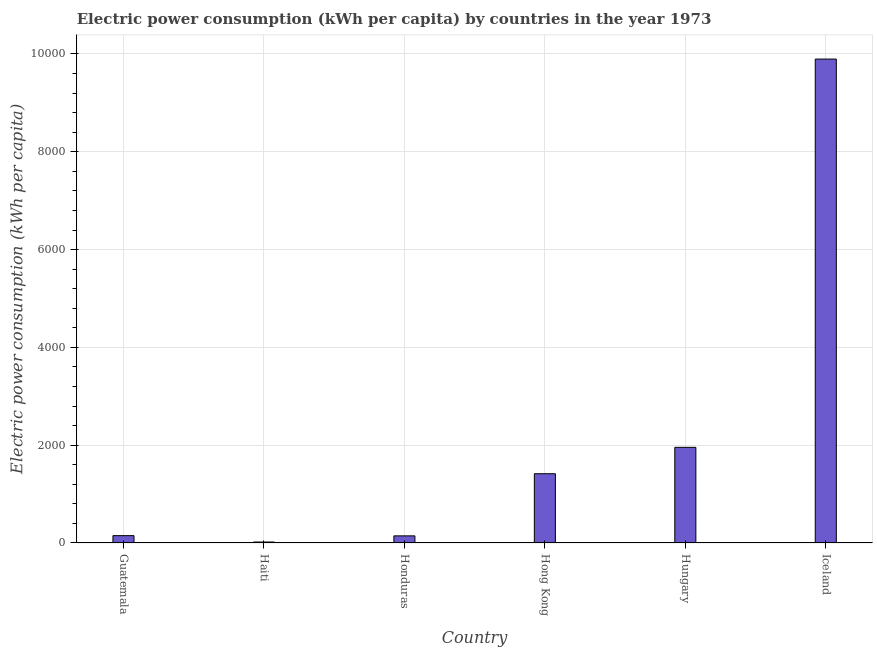Does the graph contain any zero values?
Your response must be concise. No. Does the graph contain grids?
Provide a short and direct response. Yes. What is the title of the graph?
Your response must be concise. Electric power consumption (kWh per capita) by countries in the year 1973. What is the label or title of the Y-axis?
Offer a terse response. Electric power consumption (kWh per capita). What is the electric power consumption in Haiti?
Give a very brief answer. 19.96. Across all countries, what is the maximum electric power consumption?
Keep it short and to the point. 9895.58. Across all countries, what is the minimum electric power consumption?
Ensure brevity in your answer.  19.96. In which country was the electric power consumption minimum?
Your answer should be compact. Haiti. What is the sum of the electric power consumption?
Provide a succinct answer. 1.36e+04. What is the difference between the electric power consumption in Haiti and Honduras?
Give a very brief answer. -125.53. What is the average electric power consumption per country?
Offer a very short reply. 2263.82. What is the median electric power consumption?
Provide a short and direct response. 783.2. What is the ratio of the electric power consumption in Hong Kong to that in Hungary?
Provide a short and direct response. 0.72. Is the difference between the electric power consumption in Hungary and Iceland greater than the difference between any two countries?
Your answer should be compact. No. What is the difference between the highest and the second highest electric power consumption?
Ensure brevity in your answer.  7940.07. Is the sum of the electric power consumption in Guatemala and Honduras greater than the maximum electric power consumption across all countries?
Provide a short and direct response. No. What is the difference between the highest and the lowest electric power consumption?
Give a very brief answer. 9875.62. How many bars are there?
Your response must be concise. 6. Are all the bars in the graph horizontal?
Your response must be concise. No. How many countries are there in the graph?
Make the answer very short. 6. What is the difference between two consecutive major ticks on the Y-axis?
Give a very brief answer. 2000. What is the Electric power consumption (kWh per capita) of Guatemala?
Your answer should be compact. 149.95. What is the Electric power consumption (kWh per capita) in Haiti?
Your answer should be compact. 19.96. What is the Electric power consumption (kWh per capita) of Honduras?
Offer a very short reply. 145.48. What is the Electric power consumption (kWh per capita) of Hong Kong?
Make the answer very short. 1416.45. What is the Electric power consumption (kWh per capita) in Hungary?
Provide a succinct answer. 1955.51. What is the Electric power consumption (kWh per capita) of Iceland?
Keep it short and to the point. 9895.58. What is the difference between the Electric power consumption (kWh per capita) in Guatemala and Haiti?
Ensure brevity in your answer.  129.99. What is the difference between the Electric power consumption (kWh per capita) in Guatemala and Honduras?
Your answer should be very brief. 4.47. What is the difference between the Electric power consumption (kWh per capita) in Guatemala and Hong Kong?
Your answer should be very brief. -1266.5. What is the difference between the Electric power consumption (kWh per capita) in Guatemala and Hungary?
Ensure brevity in your answer.  -1805.56. What is the difference between the Electric power consumption (kWh per capita) in Guatemala and Iceland?
Make the answer very short. -9745.63. What is the difference between the Electric power consumption (kWh per capita) in Haiti and Honduras?
Your answer should be compact. -125.53. What is the difference between the Electric power consumption (kWh per capita) in Haiti and Hong Kong?
Offer a very short reply. -1396.49. What is the difference between the Electric power consumption (kWh per capita) in Haiti and Hungary?
Offer a terse response. -1935.55. What is the difference between the Electric power consumption (kWh per capita) in Haiti and Iceland?
Provide a short and direct response. -9875.62. What is the difference between the Electric power consumption (kWh per capita) in Honduras and Hong Kong?
Your answer should be very brief. -1270.96. What is the difference between the Electric power consumption (kWh per capita) in Honduras and Hungary?
Your answer should be very brief. -1810.03. What is the difference between the Electric power consumption (kWh per capita) in Honduras and Iceland?
Give a very brief answer. -9750.1. What is the difference between the Electric power consumption (kWh per capita) in Hong Kong and Hungary?
Provide a succinct answer. -539.06. What is the difference between the Electric power consumption (kWh per capita) in Hong Kong and Iceland?
Your answer should be very brief. -8479.13. What is the difference between the Electric power consumption (kWh per capita) in Hungary and Iceland?
Your response must be concise. -7940.07. What is the ratio of the Electric power consumption (kWh per capita) in Guatemala to that in Haiti?
Your response must be concise. 7.51. What is the ratio of the Electric power consumption (kWh per capita) in Guatemala to that in Honduras?
Provide a succinct answer. 1.03. What is the ratio of the Electric power consumption (kWh per capita) in Guatemala to that in Hong Kong?
Your answer should be very brief. 0.11. What is the ratio of the Electric power consumption (kWh per capita) in Guatemala to that in Hungary?
Provide a short and direct response. 0.08. What is the ratio of the Electric power consumption (kWh per capita) in Guatemala to that in Iceland?
Your answer should be very brief. 0.01. What is the ratio of the Electric power consumption (kWh per capita) in Haiti to that in Honduras?
Make the answer very short. 0.14. What is the ratio of the Electric power consumption (kWh per capita) in Haiti to that in Hong Kong?
Offer a very short reply. 0.01. What is the ratio of the Electric power consumption (kWh per capita) in Haiti to that in Hungary?
Make the answer very short. 0.01. What is the ratio of the Electric power consumption (kWh per capita) in Haiti to that in Iceland?
Offer a terse response. 0. What is the ratio of the Electric power consumption (kWh per capita) in Honduras to that in Hong Kong?
Provide a succinct answer. 0.1. What is the ratio of the Electric power consumption (kWh per capita) in Honduras to that in Hungary?
Offer a terse response. 0.07. What is the ratio of the Electric power consumption (kWh per capita) in Honduras to that in Iceland?
Provide a short and direct response. 0.01. What is the ratio of the Electric power consumption (kWh per capita) in Hong Kong to that in Hungary?
Provide a short and direct response. 0.72. What is the ratio of the Electric power consumption (kWh per capita) in Hong Kong to that in Iceland?
Offer a terse response. 0.14. What is the ratio of the Electric power consumption (kWh per capita) in Hungary to that in Iceland?
Provide a short and direct response. 0.2. 